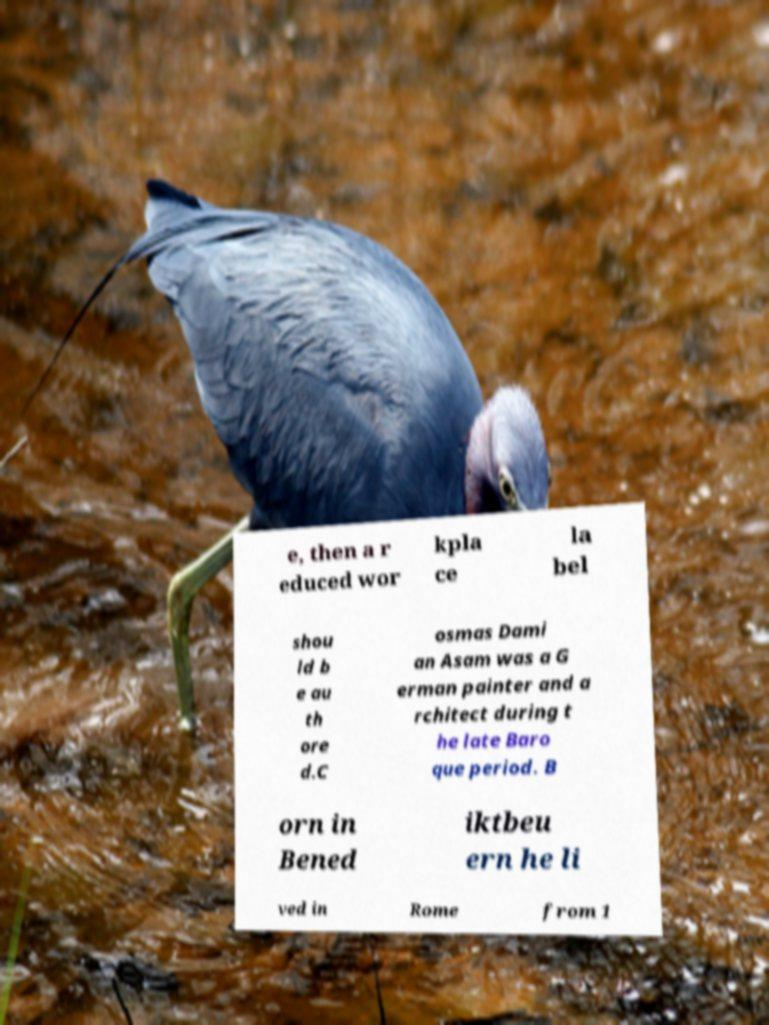Please read and relay the text visible in this image. What does it say? e, then a r educed wor kpla ce la bel shou ld b e au th ore d.C osmas Dami an Asam was a G erman painter and a rchitect during t he late Baro que period. B orn in Bened iktbeu ern he li ved in Rome from 1 